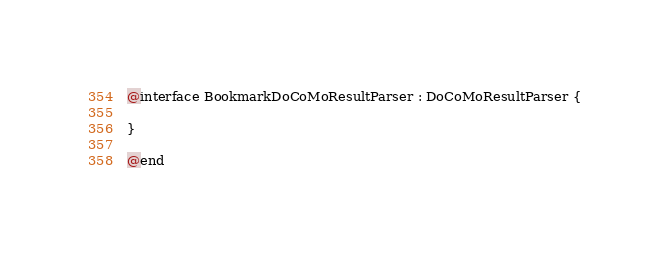Convert code to text. <code><loc_0><loc_0><loc_500><loc_500><_C_>
@interface BookmarkDoCoMoResultParser : DoCoMoResultParser {

}

@end
</code> 